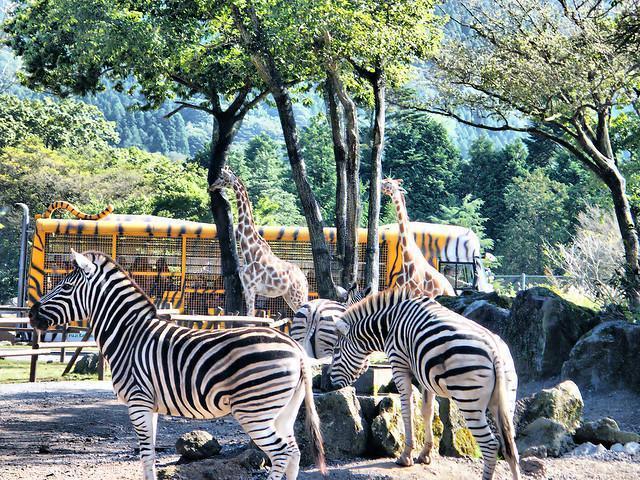How many kinds of animals are in this photo?
Give a very brief answer. 2. How many zebras are in the picture?
Give a very brief answer. 3. How many giraffes are there?
Give a very brief answer. 2. How many of the dogs are black?
Give a very brief answer. 0. 